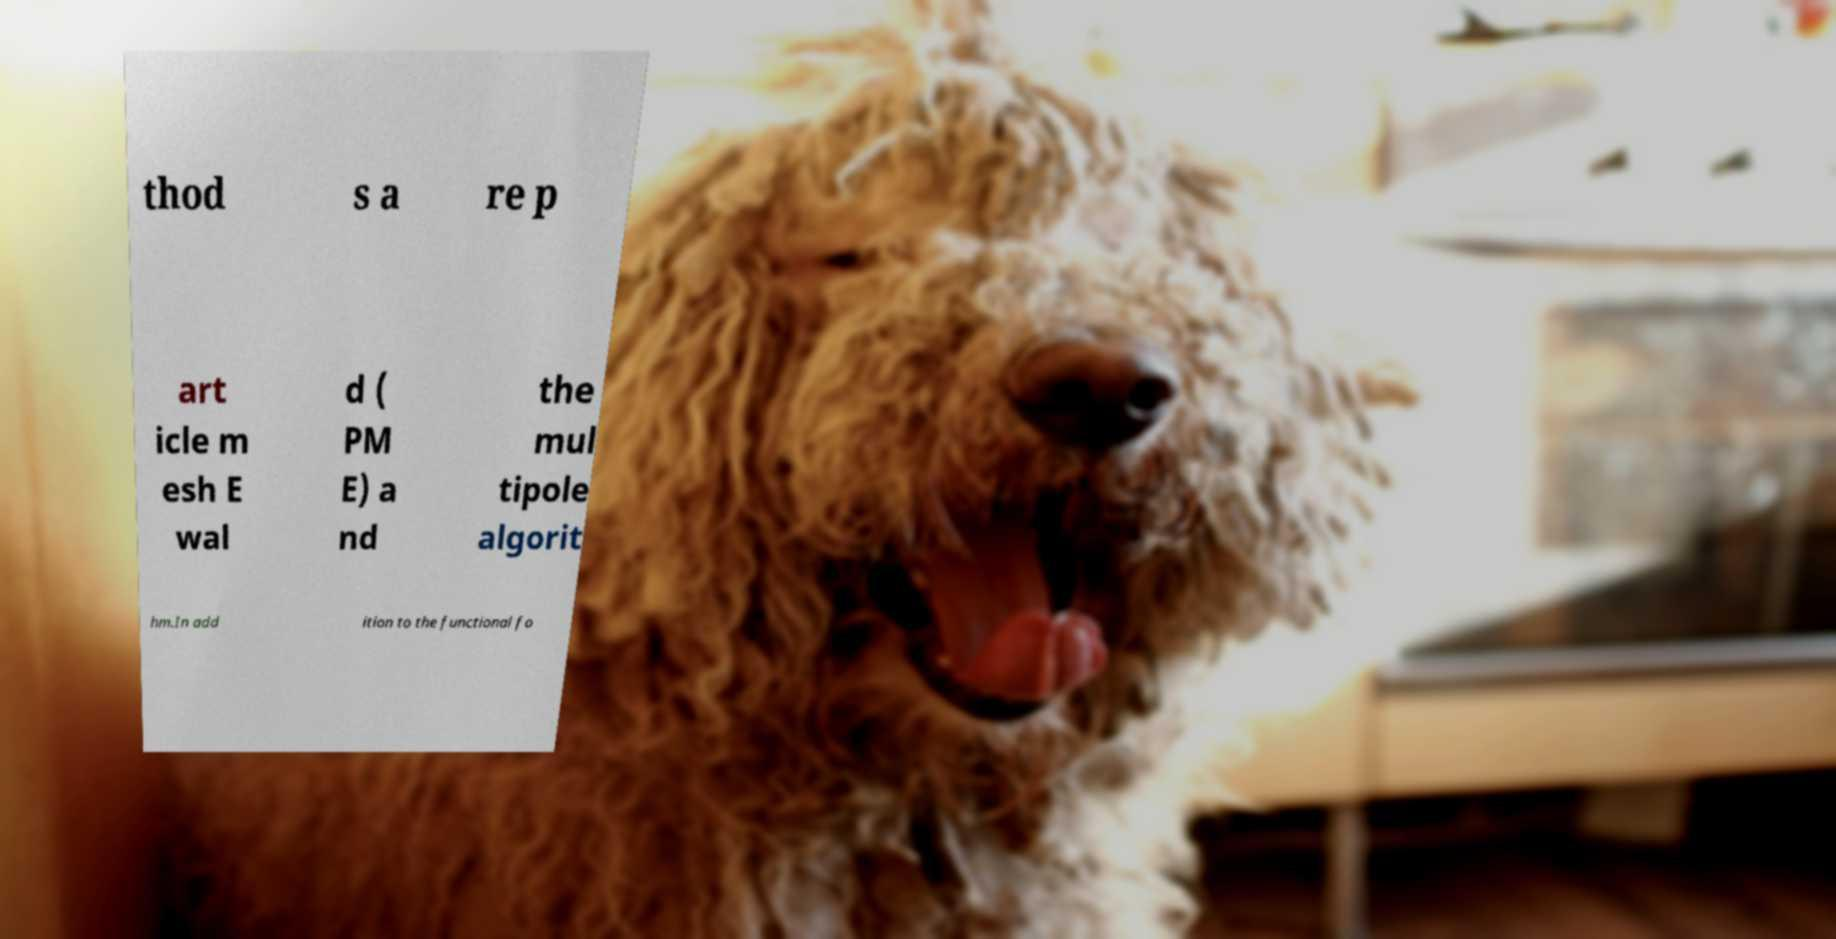Please identify and transcribe the text found in this image. thod s a re p art icle m esh E wal d ( PM E) a nd the mul tipole algorit hm.In add ition to the functional fo 